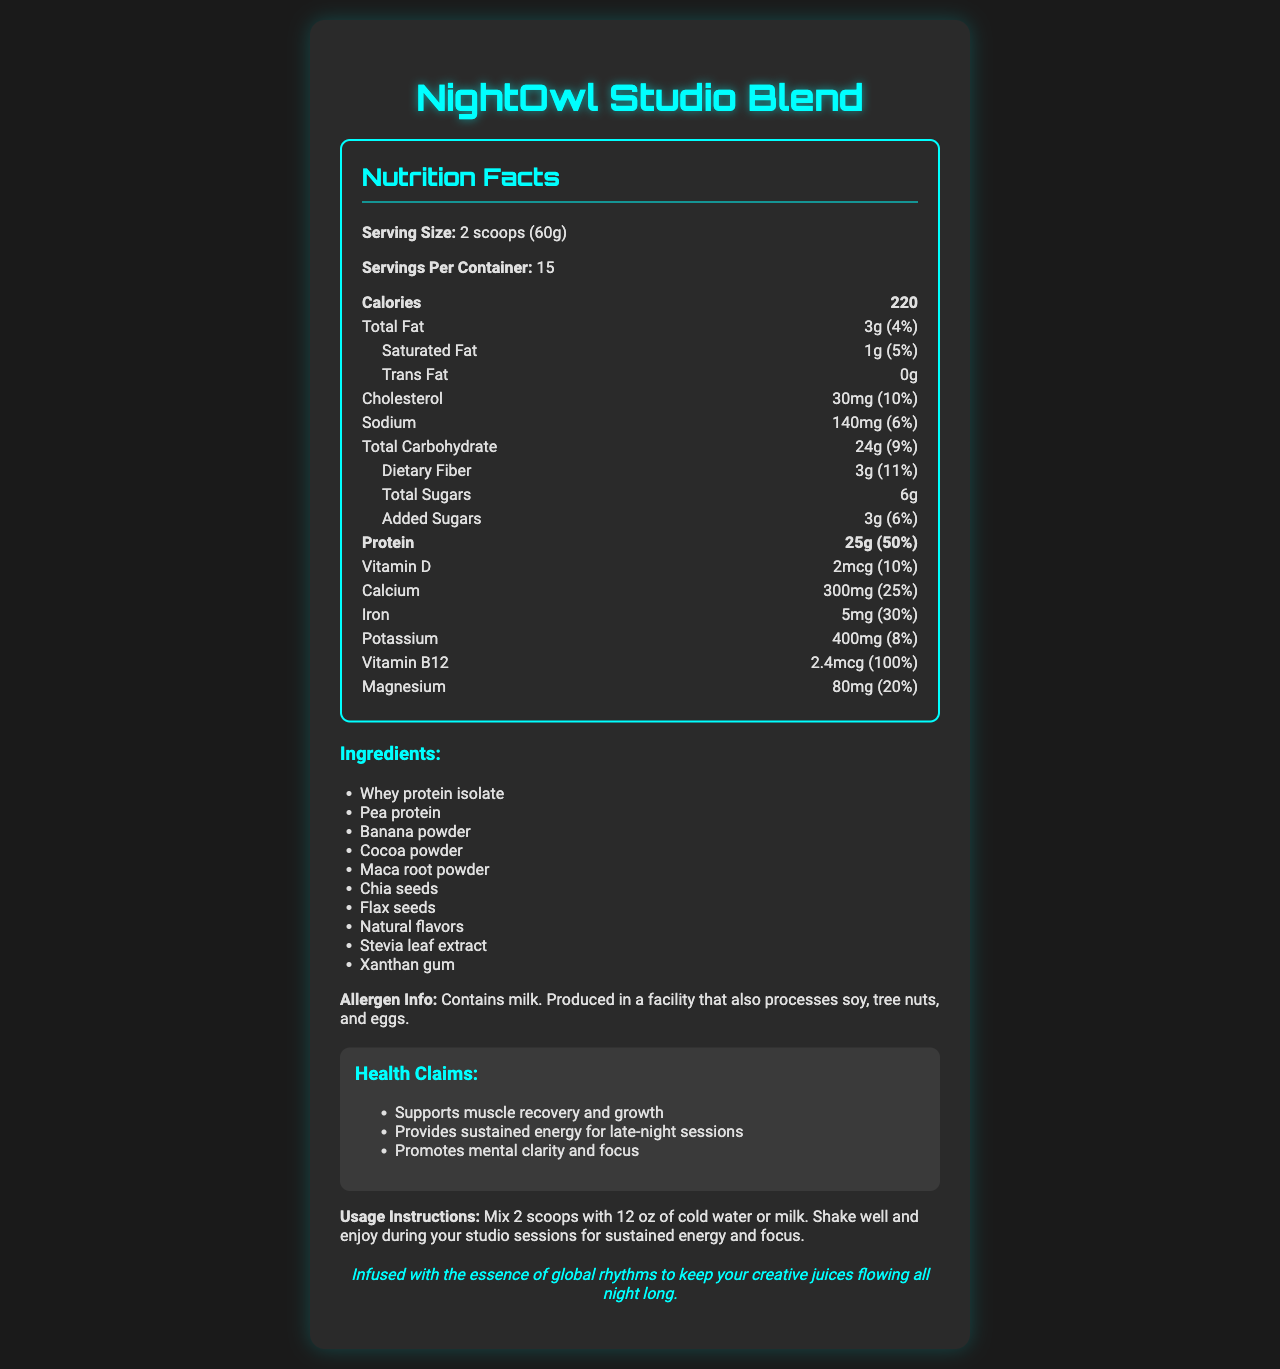what is the product name? The product name is clearly stated at the top of the document.
Answer: NightOwl Studio Blend how many calories are in one serving? The document specifies that each serving contains 220 calories.
Answer: 220 how much protein does each serving contain? The document mentions that each serving contains 25 grams of protein, which is 50% of the daily value.
Answer: 25g what is the serving size for the NightOwl Studio Blend? The serving size is clearly stated as 2 scoops (60g).
Answer: 2 scoops (60g) how many servings are in one container? The document specifies that there are 15 servings per container.
Answer: 15 how much total fat is in each serving, and what percentage of the daily value does it represent? Each serving has 3 grams of total fat, which is 4% of the daily value.
Answer: 3g (4%) which of the following ingredients is NOT listed in the document? A. Whey protein isolate B. Cocoa powder C. Sugar The listed ingredients include whey protein isolate and cocoa powder, but sugar is not listed, whereas Stevia leaf extract is mentioned as a sweetener.
Answer: C how much dietary fiber does each serving provide? Each serving provides 3 grams of dietary fiber, which is 11% of the daily value.
Answer: 3g (11%) what is the amount of added sugars in each serving? The document specifies that there are 3 grams of added sugars, which is 6% of the daily value.
Answer: 3g (6%) does the NightOwl Studio Blend contain any trans fat? The document shows that the trans fat amount is 0g.
Answer: No is the product suitable for someone with a nut allergy? The allergen information indicates that it is produced in a facility that processes tree nuts, making it potentially unsafe for someone with a nut allergy.
Answer: No what minerals are found in the NightOwl Studio Blend and their daily values? The document lists Calcium (25%), Iron (30%), Potassium (8%), and Magnesium (20%) with their respective daily values.
Answer: Calcium 25%, Iron 30%, Potassium 8%, Magnesium 20% how should the NightOwl Studio Blend be prepared? The usage instructions specify to mix 2 scoops with 12 oz of cold water or milk and shake well.
Answer: Mix 2 scoops with 12 oz of cold water or milk. Shake well. which health claim is associated with mental focus? A. Supports muscle recovery and growth B. Provides sustained energy for late-night sessions C. Promotes mental clarity and focus The document claims that the product promotes mental clarity and focus.
Answer: C what does the document suggest about the source of inspiration for the NightOwl Studio Blend? The document states that the blend is infused with the essence of global rhythms to keep creative juices flowing.
Answer: Infused with the essence of global rhythms summarize the main idea of the document. The summary covers the product's purpose, main ingredients, nutritional content, and claimed health benefits.
Answer: NightOwl Studio Blend is a protein-rich smoothie mix designed for late-night studio sessions, offering various health benefits including muscle recovery, sustained energy, and mental clarity. It contains various ingredients such as whey protein isolate and pea protein, and provides key nutrients like calcium, iron, and vitamin B12. what time of day is the NightOwl Studio Blend recommended to use? Late-night studio sessions are mentioned, but the exact time of day is not specified explicitly.
Answer: The document does not specify a time of day for using the blend. It only suggests it's good for late-night sessions. 